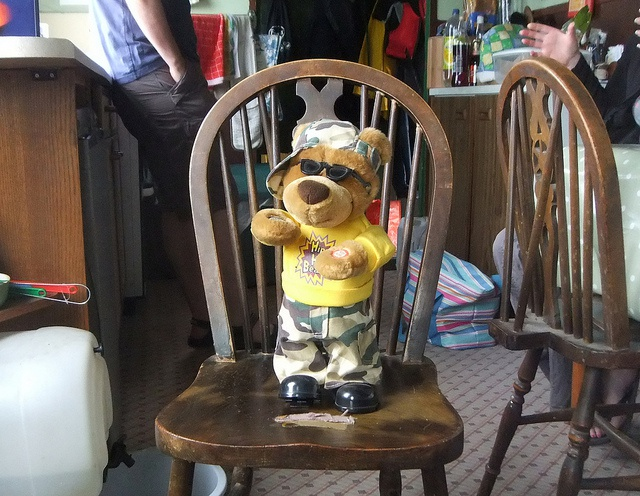Describe the objects in this image and their specific colors. I can see chair in purple, black, gray, and maroon tones, chair in purple, black, gray, and maroon tones, teddy bear in purple, khaki, ivory, black, and gray tones, people in purple, black, gray, and lavender tones, and people in purple, black, lightpink, darkgray, and gray tones in this image. 